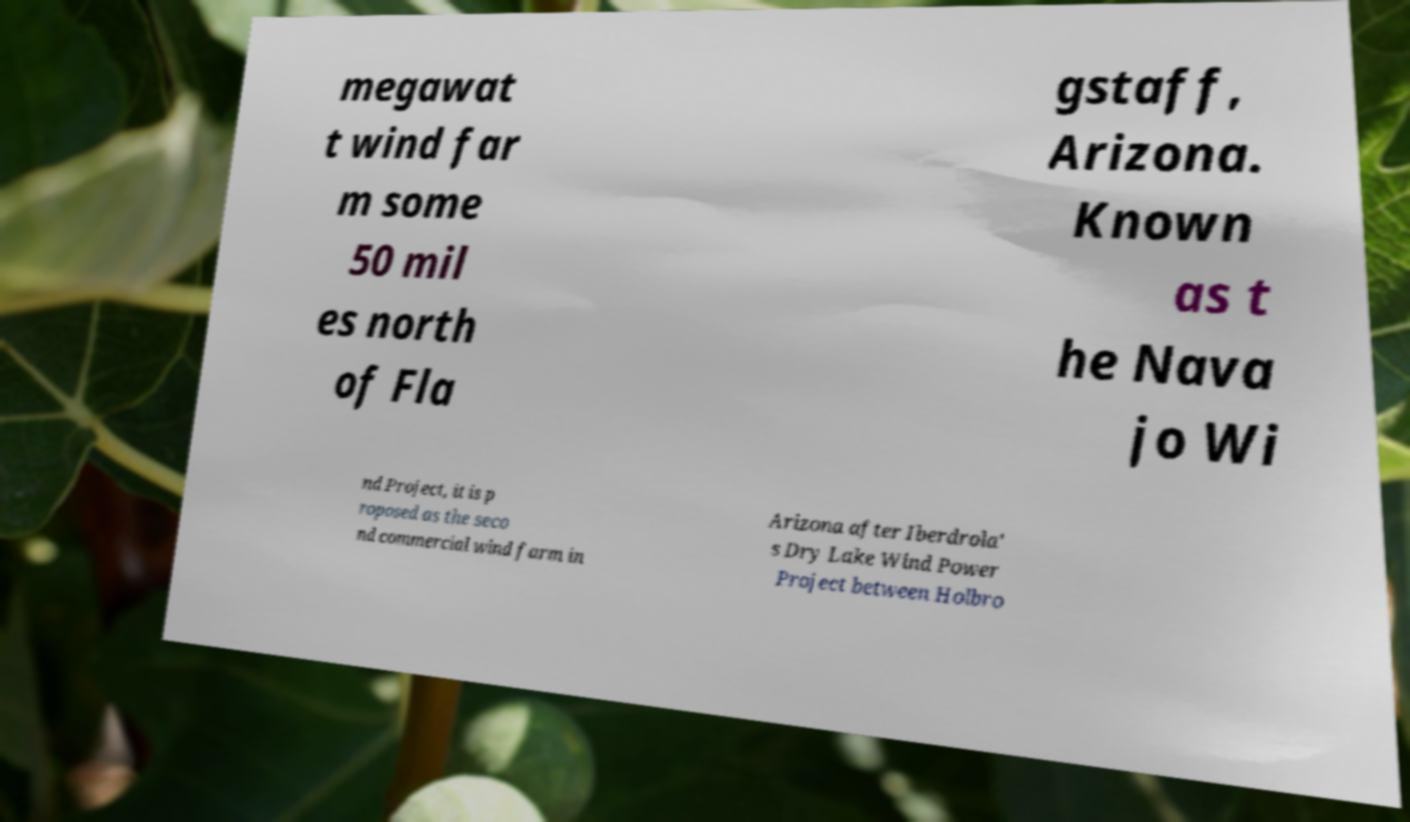Please identify and transcribe the text found in this image. megawat t wind far m some 50 mil es north of Fla gstaff, Arizona. Known as t he Nava jo Wi nd Project, it is p roposed as the seco nd commercial wind farm in Arizona after Iberdrola' s Dry Lake Wind Power Project between Holbro 